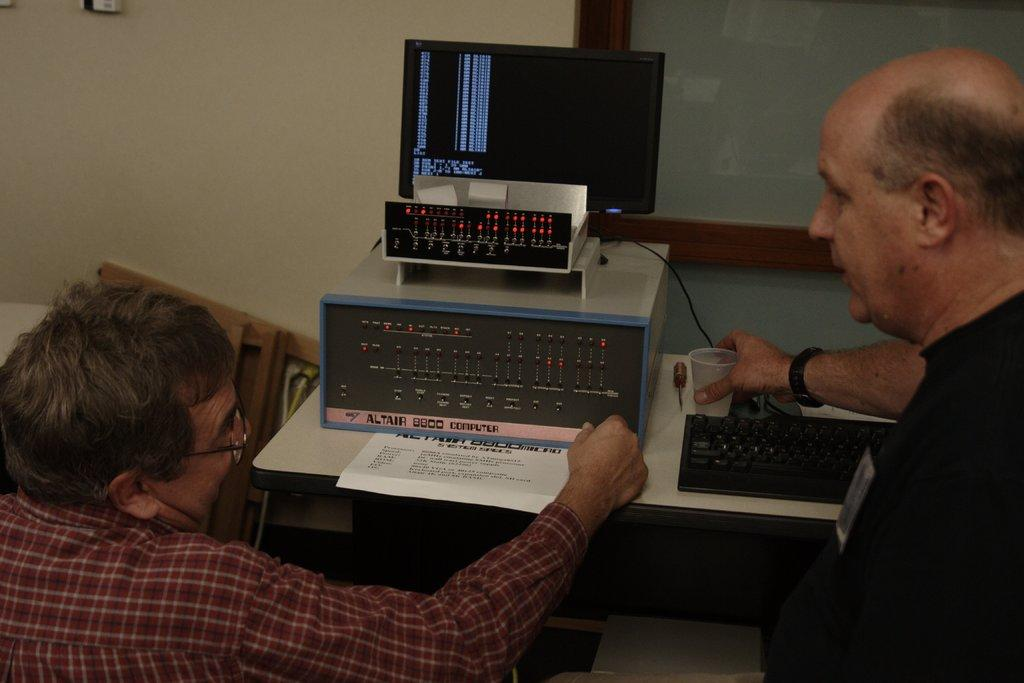<image>
Render a clear and concise summary of the photo. Two men complete work on an Altair 8800 Computer. 